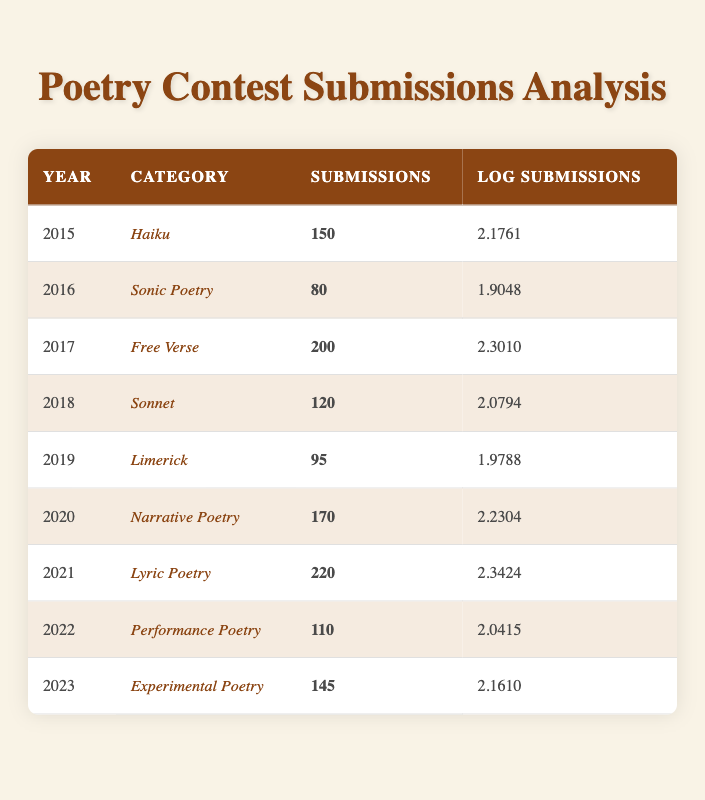What was the highest number of submissions recorded in a single year? The maximum submissions can be found by scanning through the 'Submissions' column in the table. The year with the highest value is 2021, which had 220 submissions.
Answer: 220 In which year did 'Sonic Poetry' receive the fewest submissions? By looking at the table, 'Sonic Poetry' corresponds to the year 2016, which had 80 submissions, and it is the lowest in the respective category.
Answer: 2016 What is the total number of submissions across all years? Adding up the submissions from each year: 150 + 80 + 200 + 120 + 95 + 170 + 220 + 110 + 145 = 1,300.
Answer: 1300 Is the number of submissions for 'Free Verse' greater than the average submissions for all categories? The average submissions are calculated by dividing the total submissions (1300) by the number of categories (9), which gives us approximately 144.4. 'Free Verse' had 200 submissions, which is greater than 144.4.
Answer: Yes Which category had the most submissions in 2022? Looking at the 'Submissions' column for 2022, 'Performance Poetry' recorded 110 submissions, which is the only entry for that year. Therefore, it is the most for 2022.
Answer: Performance Poetry What is the range of submissions from the years 2015 to 2023? The range can be calculated by subtracting the lowest submission (80 in 2016) from the highest submission (220 in 2021). So, the range is 220 - 80 = 140.
Answer: 140 Did 'Limerick' have more submissions than 'Haiku' in 2019? Comparing the submissions, 'Limerick' had 95 submissions while 'Haiku' had 150 in 2015. Since 150 is greater, it confirms that 'Limerick' had less than 'Haiku'.
Answer: No How many categories had submissions equal to or above 100 in 2020? In 2020, 'Narrative Poetry' had 170 submissions (which is above 100). Scanning through all categories, we find that in total, four categories had submissions over 100: 'Haiku' (150), 'Narrative Poetry' (170), 'Lyric Poetry' (220), and 'Performance Poetry' (110).
Answer: 4 